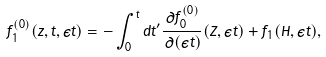<formula> <loc_0><loc_0><loc_500><loc_500>f _ { 1 } ^ { ( 0 ) } ( { z } , t , \epsilon t ) = - \int _ { 0 } ^ { t } d t ^ { \prime } \frac { \partial f _ { 0 } ^ { ( 0 ) } } { \partial ( \epsilon t ) } ( { Z } , \epsilon t ) + f _ { 1 } ( H , \epsilon t ) ,</formula> 